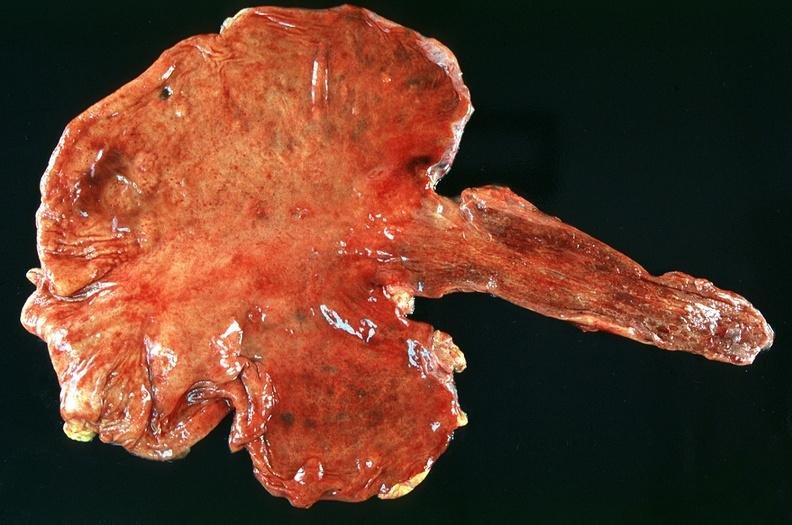s cranial artery present?
Answer the question using a single word or phrase. No 